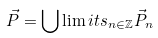<formula> <loc_0><loc_0><loc_500><loc_500>\vec { P } = \bigcup \lim i t s _ { n \in \mathbb { Z } } \vec { P } _ { n }</formula> 